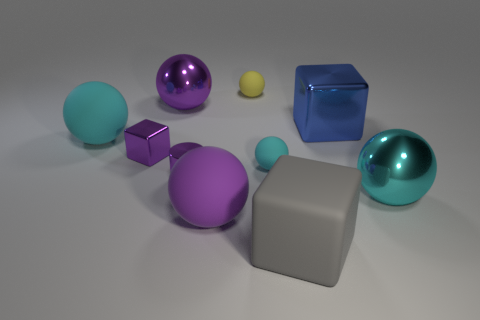How many balls are either blue objects or tiny matte objects?
Ensure brevity in your answer.  2. What is the size of the purple sphere that is in front of the rubber ball that is right of the tiny rubber object that is behind the big blue block?
Ensure brevity in your answer.  Large. The object that is behind the cylinder and on the right side of the gray cube is what color?
Your answer should be very brief. Blue. There is a purple matte thing; is its size the same as the shiny ball that is to the left of the large gray thing?
Your answer should be very brief. Yes. Are there any other things that are the same shape as the large gray thing?
Offer a very short reply. Yes. There is another large matte thing that is the same shape as the purple matte thing; what color is it?
Offer a very short reply. Cyan. Do the yellow ball and the gray matte cube have the same size?
Offer a very short reply. No. How many other objects are the same size as the rubber block?
Give a very brief answer. 5. What number of objects are things left of the small yellow matte sphere or metallic cubes that are in front of the large blue metallic block?
Your response must be concise. 5. What is the shape of the blue metallic object that is the same size as the matte block?
Your answer should be very brief. Cube. 